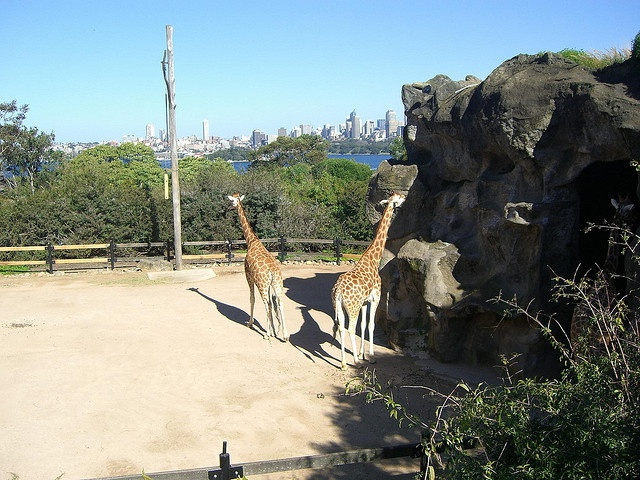Describe the objects in this image and their specific colors. I can see giraffe in lightblue, ivory, khaki, black, and tan tones and giraffe in lightblue, beige, and tan tones in this image. 